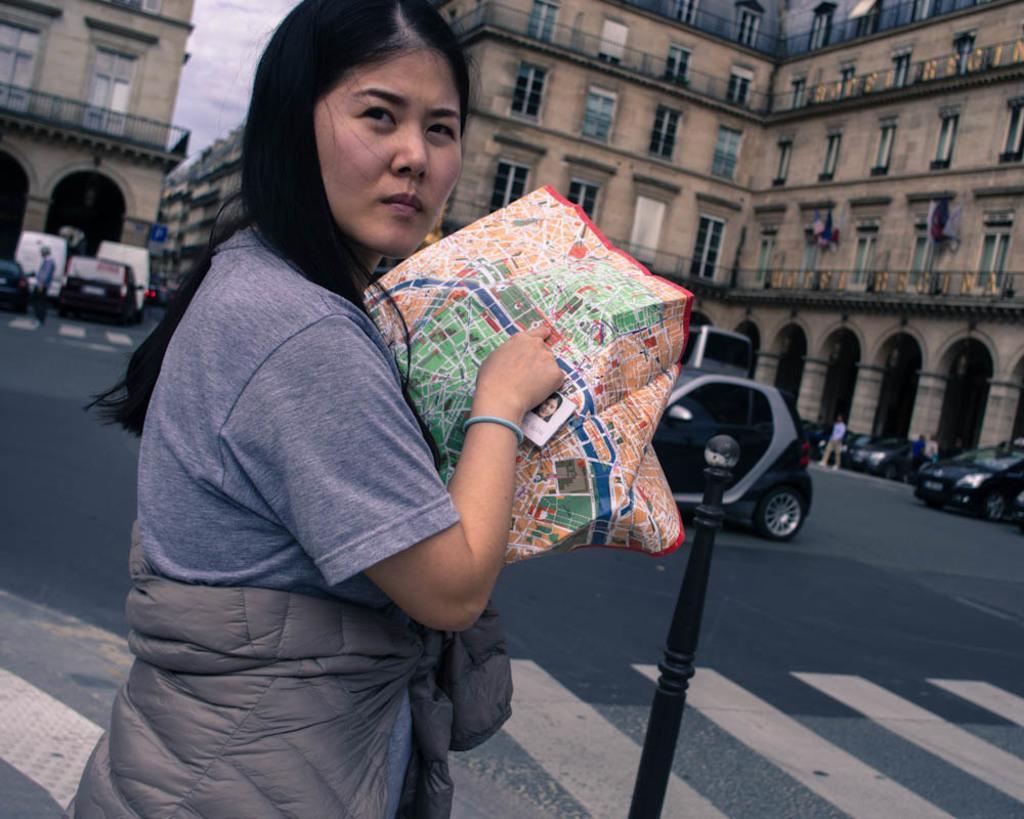Can you describe this image briefly? There is a woman standing and holding a bag,in front of this woman we can see pole. In the background we can see buildings,vehicles on the road,people and sky. 